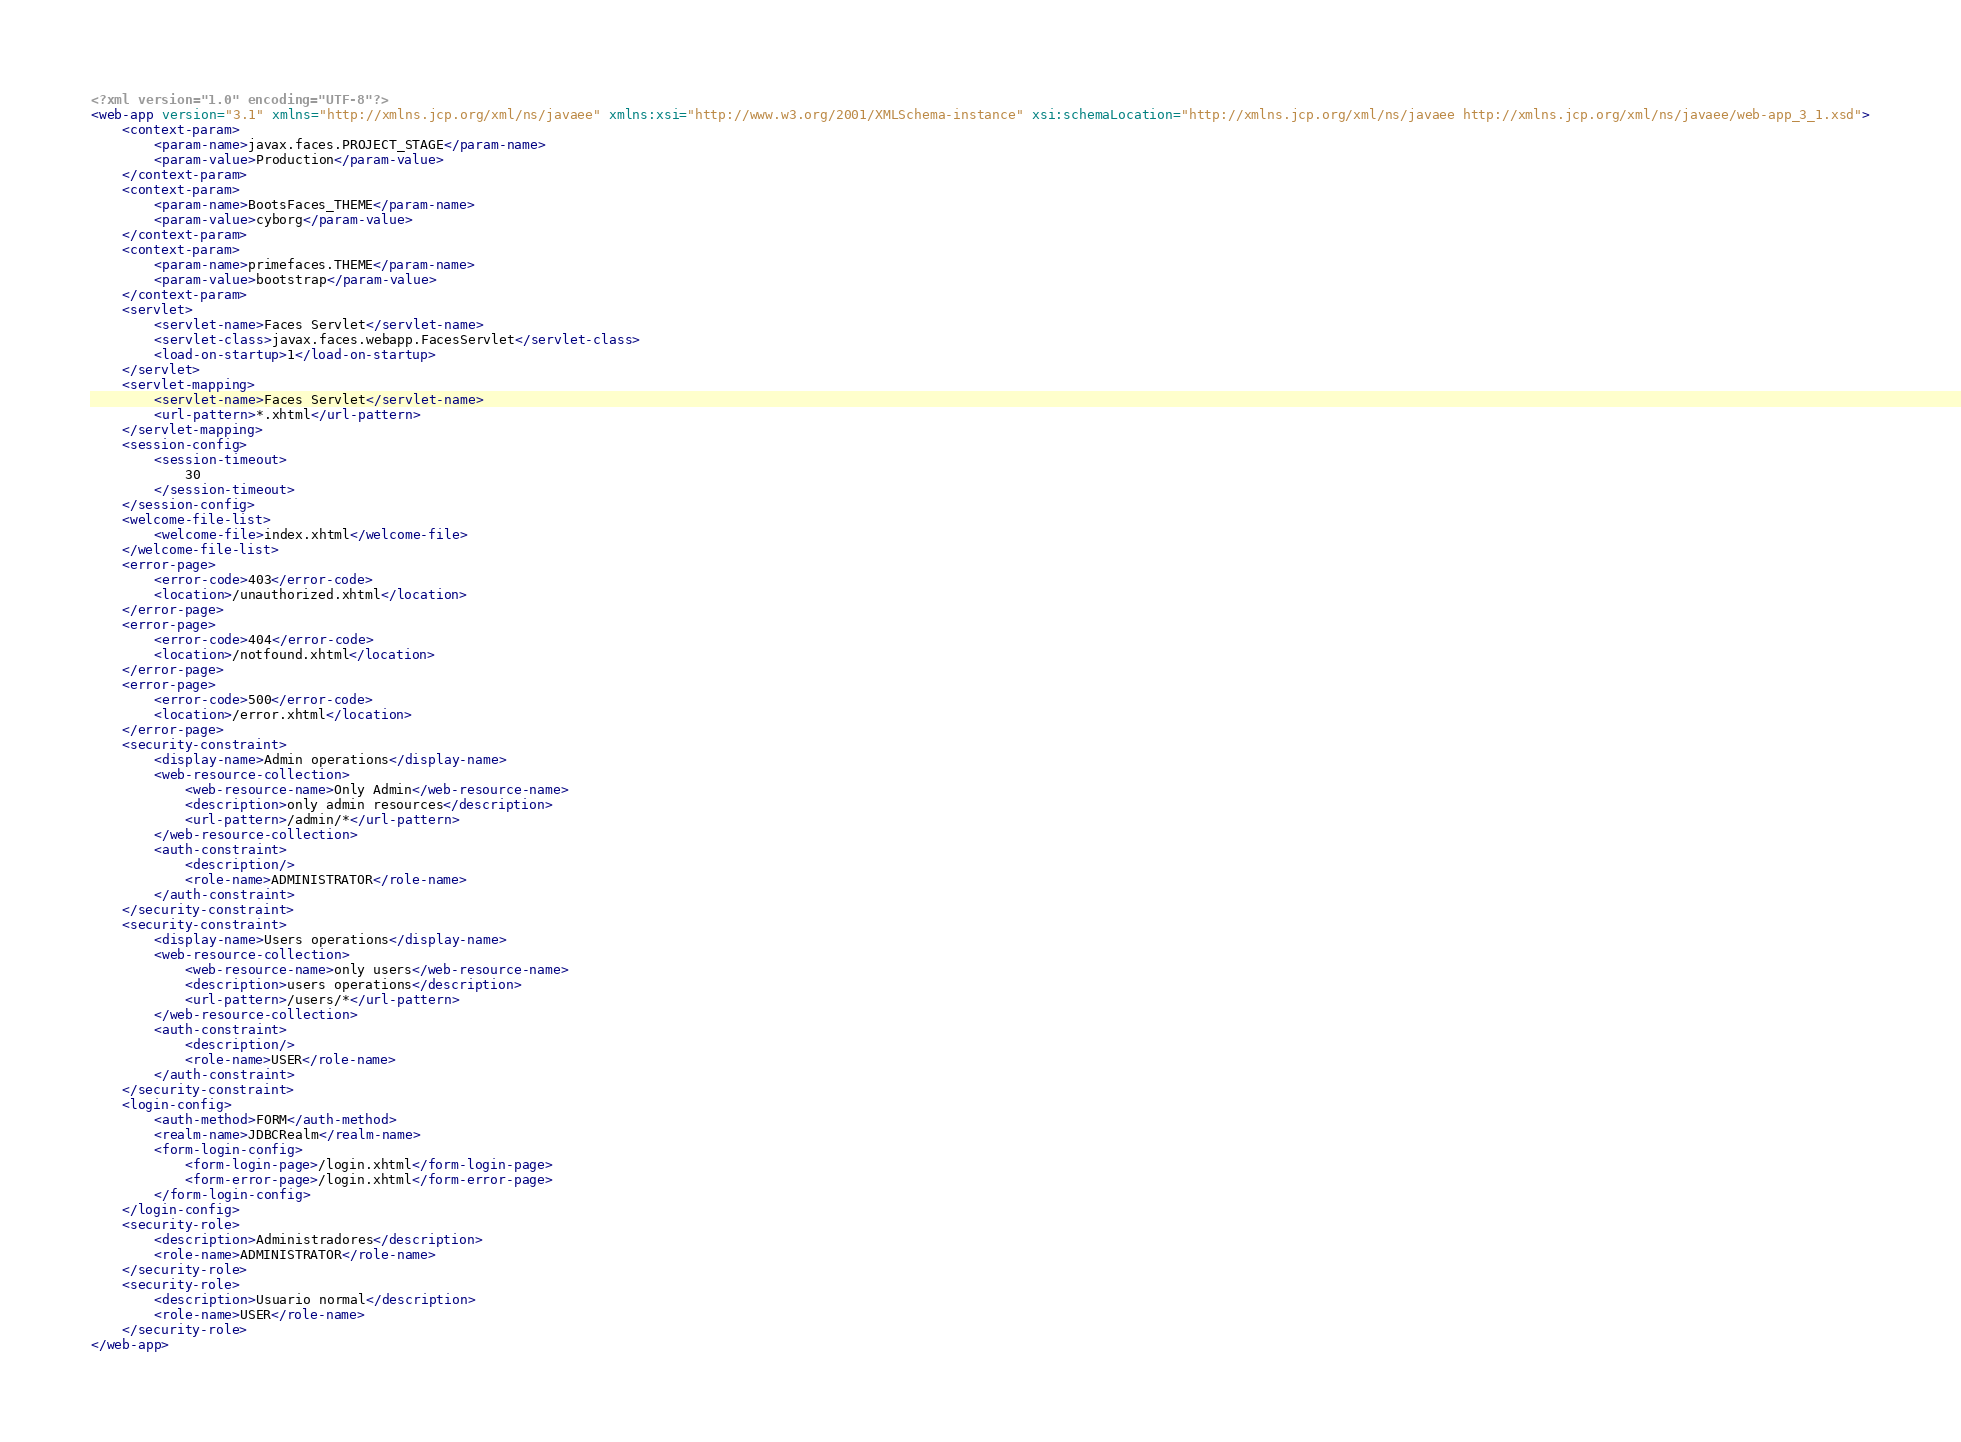<code> <loc_0><loc_0><loc_500><loc_500><_XML_><?xml version="1.0" encoding="UTF-8"?>
<web-app version="3.1" xmlns="http://xmlns.jcp.org/xml/ns/javaee" xmlns:xsi="http://www.w3.org/2001/XMLSchema-instance" xsi:schemaLocation="http://xmlns.jcp.org/xml/ns/javaee http://xmlns.jcp.org/xml/ns/javaee/web-app_3_1.xsd">
    <context-param>
        <param-name>javax.faces.PROJECT_STAGE</param-name>
        <param-value>Production</param-value>
    </context-param>
    <context-param>
        <param-name>BootsFaces_THEME</param-name>
        <param-value>cyborg</param-value>
    </context-param>
    <context-param>
        <param-name>primefaces.THEME</param-name>
        <param-value>bootstrap</param-value>
    </context-param>
    <servlet>
        <servlet-name>Faces Servlet</servlet-name>
        <servlet-class>javax.faces.webapp.FacesServlet</servlet-class>
        <load-on-startup>1</load-on-startup>
    </servlet>
    <servlet-mapping>
        <servlet-name>Faces Servlet</servlet-name>
        <url-pattern>*.xhtml</url-pattern>
    </servlet-mapping>
    <session-config>
        <session-timeout>
            30
        </session-timeout>
    </session-config>
    <welcome-file-list>
        <welcome-file>index.xhtml</welcome-file>
    </welcome-file-list>
    <error-page>
        <error-code>403</error-code>
        <location>/unauthorized.xhtml</location>
    </error-page>
    <error-page>
        <error-code>404</error-code>
        <location>/notfound.xhtml</location>
    </error-page>
    <error-page>
        <error-code>500</error-code>
        <location>/error.xhtml</location>
    </error-page>
    <security-constraint>
        <display-name>Admin operations</display-name>
        <web-resource-collection>
            <web-resource-name>Only Admin</web-resource-name>
            <description>only admin resources</description>
            <url-pattern>/admin/*</url-pattern>
        </web-resource-collection>
        <auth-constraint>
            <description/>
            <role-name>ADMINISTRATOR</role-name>
        </auth-constraint>
    </security-constraint>
    <security-constraint>
        <display-name>Users operations</display-name>
        <web-resource-collection>
            <web-resource-name>only users</web-resource-name>
            <description>users operations</description>
            <url-pattern>/users/*</url-pattern>
        </web-resource-collection>
        <auth-constraint>
            <description/>
            <role-name>USER</role-name>
        </auth-constraint>
    </security-constraint>
    <login-config>
        <auth-method>FORM</auth-method>
        <realm-name>JDBCRealm</realm-name>
        <form-login-config>
            <form-login-page>/login.xhtml</form-login-page>
            <form-error-page>/login.xhtml</form-error-page>
        </form-login-config>
    </login-config>
    <security-role>
        <description>Administradores</description>
        <role-name>ADMINISTRATOR</role-name>
    </security-role>
    <security-role>
        <description>Usuario normal</description>
        <role-name>USER</role-name>
    </security-role>
</web-app>
</code> 